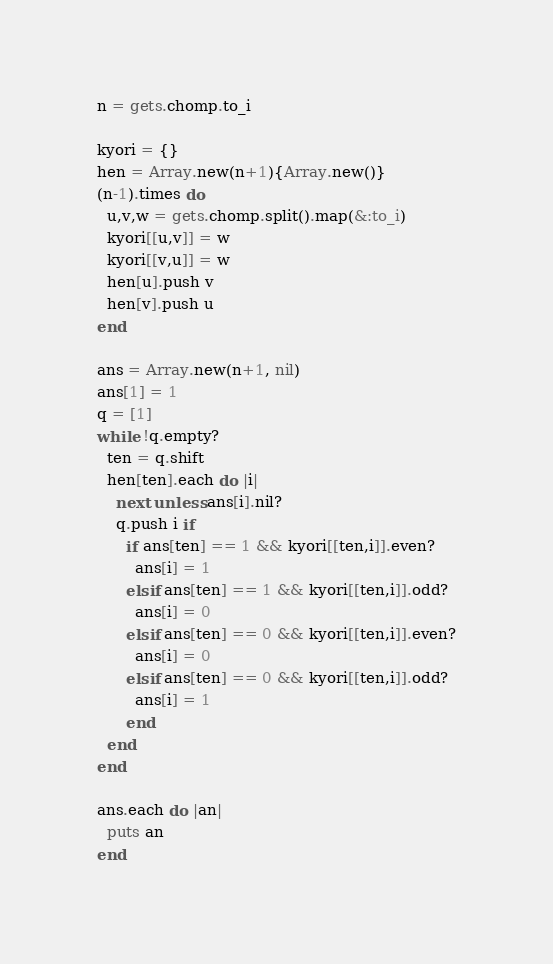Convert code to text. <code><loc_0><loc_0><loc_500><loc_500><_Ruby_>n = gets.chomp.to_i

kyori = {}
hen = Array.new(n+1){Array.new()}
(n-1).times do
  u,v,w = gets.chomp.split().map(&:to_i)
  kyori[[u,v]] = w
  kyori[[v,u]] = w
  hen[u].push v
  hen[v].push u
end

ans = Array.new(n+1, nil)
ans[1] = 1
q = [1]
while !q.empty?
  ten = q.shift
  hen[ten].each do |i|
    next unless ans[i].nil?
    q.push i if
      if ans[ten] == 1 && kyori[[ten,i]].even?
        ans[i] = 1
      elsif ans[ten] == 1 && kyori[[ten,i]].odd?
        ans[i] = 0
      elsif ans[ten] == 0 && kyori[[ten,i]].even?
        ans[i] = 0
      elsif ans[ten] == 0 && kyori[[ten,i]].odd?
        ans[i] = 1
      end
  end
end

ans.each do |an|
  puts an
end
</code> 